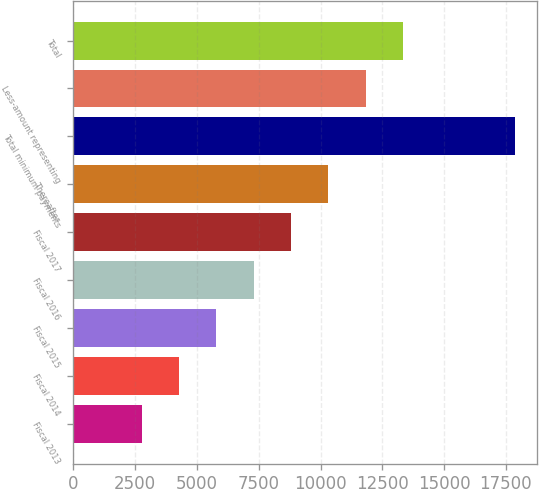Convert chart to OTSL. <chart><loc_0><loc_0><loc_500><loc_500><bar_chart><fcel>Fiscal 2013<fcel>Fiscal 2014<fcel>Fiscal 2015<fcel>Fiscal 2016<fcel>Fiscal 2017<fcel>Thereafter<fcel>Total minimum payments<fcel>Less-amount representing<fcel>Total<nl><fcel>2764<fcel>4274.3<fcel>5784.6<fcel>7294.9<fcel>8805.2<fcel>10315.5<fcel>17867<fcel>11825.8<fcel>13336.1<nl></chart> 